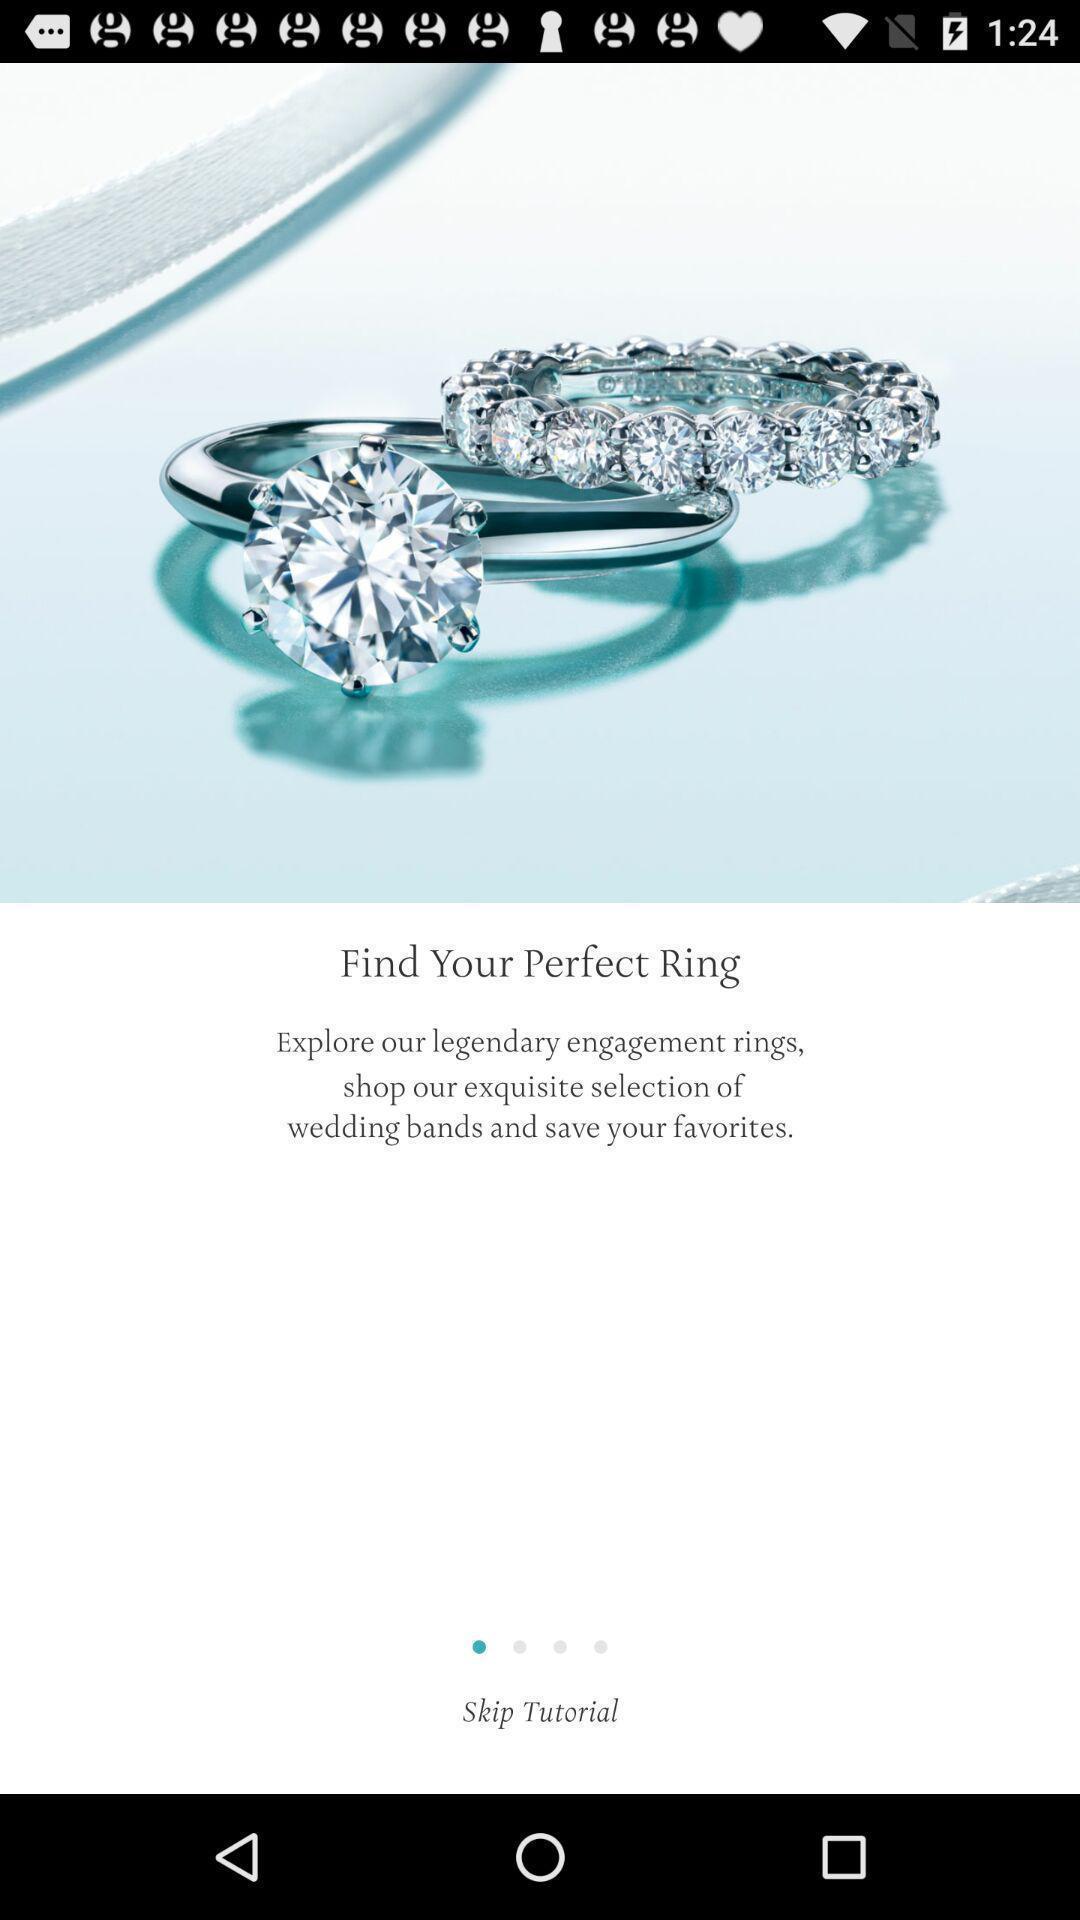Explain the elements present in this screenshot. Welcome page for a jewellery app. 